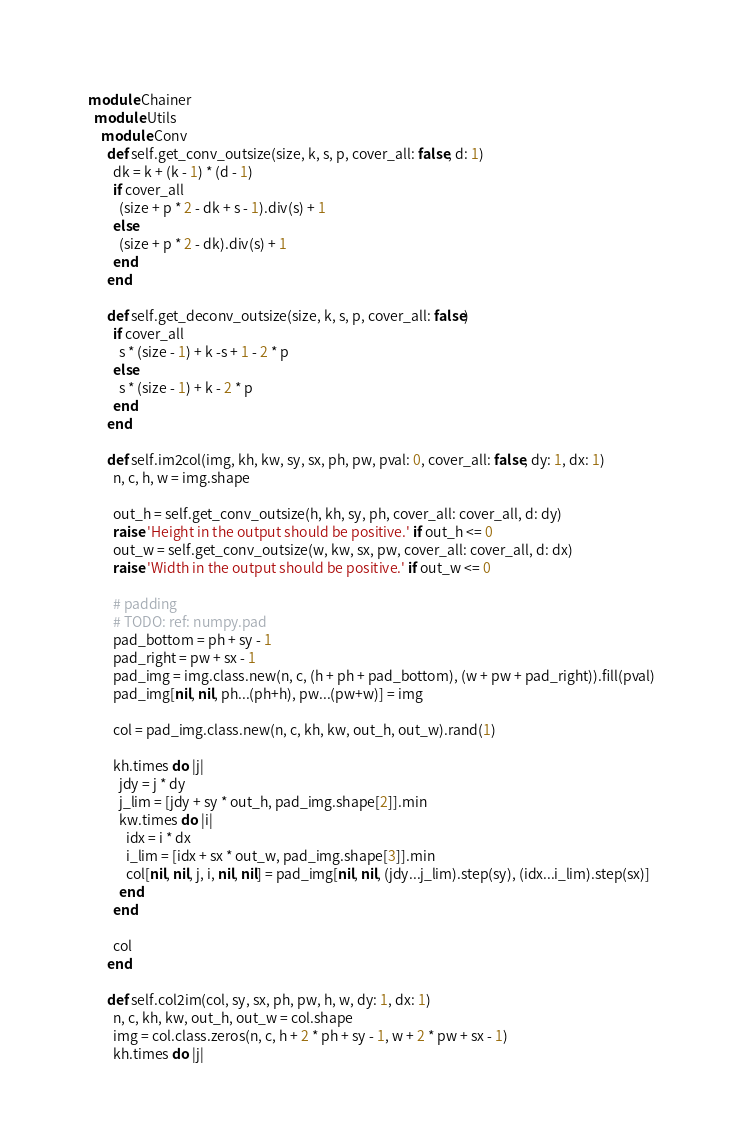Convert code to text. <code><loc_0><loc_0><loc_500><loc_500><_Ruby_>module Chainer
  module Utils
    module Conv
      def self.get_conv_outsize(size, k, s, p, cover_all: false, d: 1)
        dk = k + (k - 1) * (d - 1)
        if cover_all
          (size + p * 2 - dk + s - 1).div(s) + 1
        else
          (size + p * 2 - dk).div(s) + 1
        end
      end

      def self.get_deconv_outsize(size, k, s, p, cover_all: false)
        if cover_all
          s * (size - 1) + k -s + 1 - 2 * p
        else
          s * (size - 1) + k - 2 * p
        end
      end

      def self.im2col(img, kh, kw, sy, sx, ph, pw, pval: 0, cover_all: false, dy: 1, dx: 1)
        n, c, h, w = img.shape

        out_h = self.get_conv_outsize(h, kh, sy, ph, cover_all: cover_all, d: dy)
        raise 'Height in the output should be positive.' if out_h <= 0
        out_w = self.get_conv_outsize(w, kw, sx, pw, cover_all: cover_all, d: dx)
        raise 'Width in the output should be positive.' if out_w <= 0

        # padding
        # TODO: ref: numpy.pad
        pad_bottom = ph + sy - 1
        pad_right = pw + sx - 1
        pad_img = img.class.new(n, c, (h + ph + pad_bottom), (w + pw + pad_right)).fill(pval)
        pad_img[nil, nil, ph...(ph+h), pw...(pw+w)] = img

        col = pad_img.class.new(n, c, kh, kw, out_h, out_w).rand(1)

        kh.times do |j|
          jdy = j * dy
          j_lim = [jdy + sy * out_h, pad_img.shape[2]].min
          kw.times do |i|
            idx = i * dx
            i_lim = [idx + sx * out_w, pad_img.shape[3]].min
            col[nil, nil, j, i, nil, nil] = pad_img[nil, nil, (jdy...j_lim).step(sy), (idx...i_lim).step(sx)]
          end
        end

        col
      end

      def self.col2im(col, sy, sx, ph, pw, h, w, dy: 1, dx: 1)
        n, c, kh, kw, out_h, out_w = col.shape
        img = col.class.zeros(n, c, h + 2 * ph + sy - 1, w + 2 * pw + sx - 1)
        kh.times do |j|</code> 